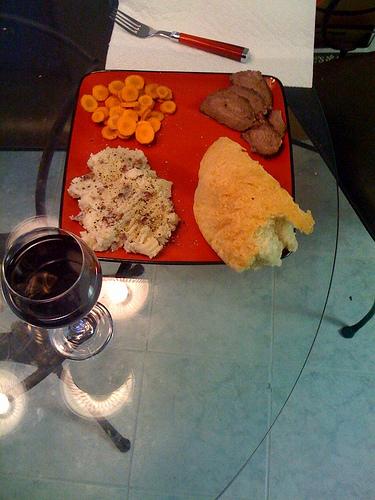Is there a glass of wine?
Write a very short answer. Yes. Is there carrots on the plate?
Write a very short answer. Yes. What kind of table is the food on?
Be succinct. Glass. 